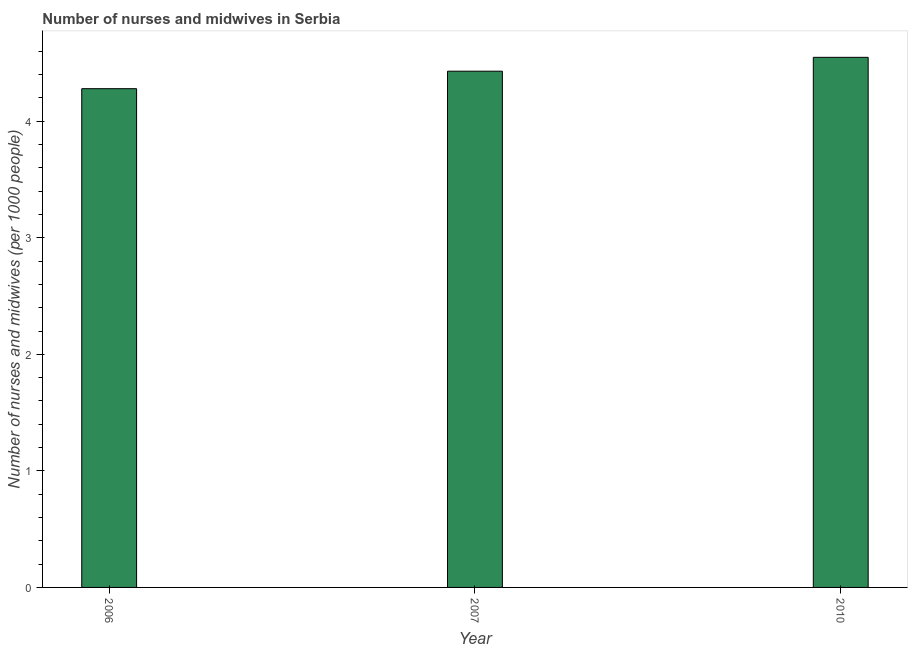What is the title of the graph?
Offer a terse response. Number of nurses and midwives in Serbia. What is the label or title of the X-axis?
Offer a very short reply. Year. What is the label or title of the Y-axis?
Provide a short and direct response. Number of nurses and midwives (per 1000 people). What is the number of nurses and midwives in 2010?
Provide a short and direct response. 4.55. Across all years, what is the maximum number of nurses and midwives?
Your response must be concise. 4.55. Across all years, what is the minimum number of nurses and midwives?
Your answer should be very brief. 4.28. In which year was the number of nurses and midwives minimum?
Your answer should be very brief. 2006. What is the sum of the number of nurses and midwives?
Offer a terse response. 13.26. What is the difference between the number of nurses and midwives in 2006 and 2010?
Provide a short and direct response. -0.27. What is the average number of nurses and midwives per year?
Make the answer very short. 4.42. What is the median number of nurses and midwives?
Provide a succinct answer. 4.43. Do a majority of the years between 2010 and 2007 (inclusive) have number of nurses and midwives greater than 1.8 ?
Provide a short and direct response. No. Is the difference between the number of nurses and midwives in 2006 and 2010 greater than the difference between any two years?
Offer a terse response. Yes. What is the difference between the highest and the second highest number of nurses and midwives?
Keep it short and to the point. 0.12. Is the sum of the number of nurses and midwives in 2006 and 2010 greater than the maximum number of nurses and midwives across all years?
Give a very brief answer. Yes. What is the difference between the highest and the lowest number of nurses and midwives?
Your response must be concise. 0.27. How many bars are there?
Your answer should be very brief. 3. How many years are there in the graph?
Provide a short and direct response. 3. What is the Number of nurses and midwives (per 1000 people) of 2006?
Your answer should be very brief. 4.28. What is the Number of nurses and midwives (per 1000 people) of 2007?
Provide a short and direct response. 4.43. What is the Number of nurses and midwives (per 1000 people) in 2010?
Provide a succinct answer. 4.55. What is the difference between the Number of nurses and midwives (per 1000 people) in 2006 and 2007?
Ensure brevity in your answer.  -0.15. What is the difference between the Number of nurses and midwives (per 1000 people) in 2006 and 2010?
Ensure brevity in your answer.  -0.27. What is the difference between the Number of nurses and midwives (per 1000 people) in 2007 and 2010?
Provide a succinct answer. -0.12. What is the ratio of the Number of nurses and midwives (per 1000 people) in 2006 to that in 2007?
Your answer should be very brief. 0.97. What is the ratio of the Number of nurses and midwives (per 1000 people) in 2006 to that in 2010?
Your answer should be very brief. 0.94. 